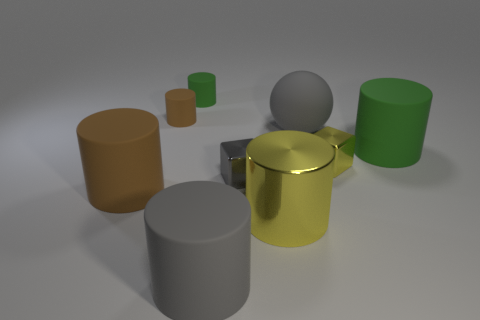Is there anything else that has the same shape as the large brown object?
Ensure brevity in your answer.  Yes. There is a green cylinder in front of the gray ball; are there any tiny cylinders that are to the left of it?
Your answer should be compact. Yes. Are there fewer big brown things that are on the right side of the gray shiny block than large gray things that are left of the large sphere?
Your answer should be compact. Yes. How big is the green matte thing that is in front of the small matte cylinder right of the tiny matte cylinder that is in front of the small green matte cylinder?
Give a very brief answer. Large. There is a brown rubber thing that is behind the gray block; is its size the same as the large green object?
Offer a terse response. No. What number of other things are the same material as the big yellow thing?
Make the answer very short. 2. Are there more big green matte cylinders than yellow things?
Your response must be concise. No. There is a green object behind the brown rubber thing that is behind the green thing to the right of the tiny green rubber thing; what is its material?
Provide a succinct answer. Rubber. Is the ball the same color as the metallic cylinder?
Provide a succinct answer. No. Is there a metal object that has the same color as the big metal cylinder?
Offer a very short reply. Yes. 